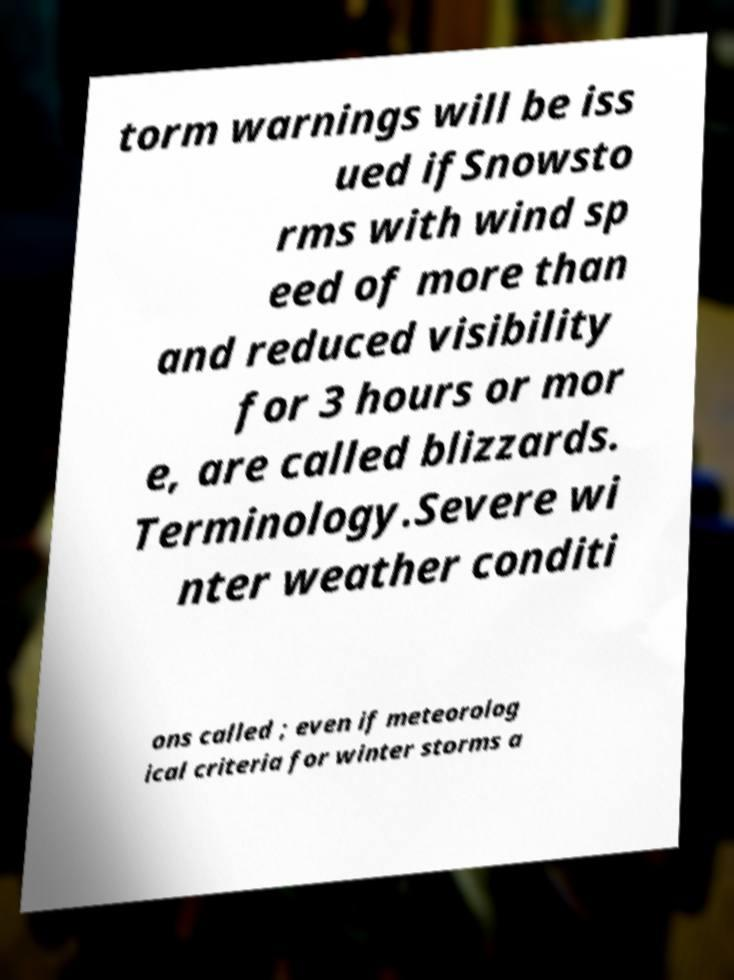Please read and relay the text visible in this image. What does it say? torm warnings will be iss ued ifSnowsto rms with wind sp eed of more than and reduced visibility for 3 hours or mor e, are called blizzards. Terminology.Severe wi nter weather conditi ons called ; even if meteorolog ical criteria for winter storms a 